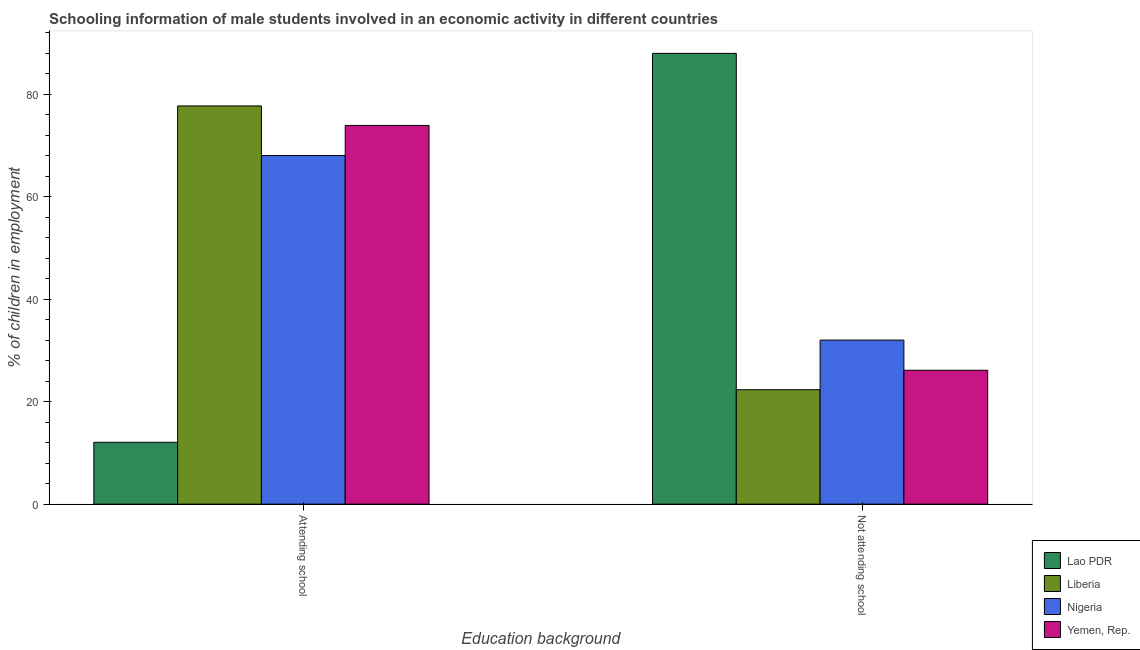How many different coloured bars are there?
Ensure brevity in your answer.  4. Are the number of bars per tick equal to the number of legend labels?
Your response must be concise. Yes. Are the number of bars on each tick of the X-axis equal?
Ensure brevity in your answer.  Yes. How many bars are there on the 2nd tick from the right?
Your response must be concise. 4. What is the label of the 1st group of bars from the left?
Give a very brief answer. Attending school. What is the percentage of employed males who are attending school in Liberia?
Your answer should be very brief. 77.68. Across all countries, what is the maximum percentage of employed males who are not attending school?
Provide a short and direct response. 87.93. Across all countries, what is the minimum percentage of employed males who are not attending school?
Make the answer very short. 22.32. In which country was the percentage of employed males who are not attending school maximum?
Give a very brief answer. Lao PDR. In which country was the percentage of employed males who are attending school minimum?
Offer a terse response. Lao PDR. What is the total percentage of employed males who are not attending school in the graph?
Offer a very short reply. 168.38. What is the difference between the percentage of employed males who are attending school in Liberia and that in Yemen, Rep.?
Give a very brief answer. 3.8. What is the difference between the percentage of employed males who are not attending school in Nigeria and the percentage of employed males who are attending school in Yemen, Rep.?
Offer a terse response. -41.88. What is the average percentage of employed males who are not attending school per country?
Ensure brevity in your answer.  42.09. What is the difference between the percentage of employed males who are not attending school and percentage of employed males who are attending school in Yemen, Rep.?
Ensure brevity in your answer.  -47.76. In how many countries, is the percentage of employed males who are not attending school greater than 16 %?
Keep it short and to the point. 4. What is the ratio of the percentage of employed males who are not attending school in Liberia to that in Lao PDR?
Provide a short and direct response. 0.25. Is the percentage of employed males who are not attending school in Liberia less than that in Yemen, Rep.?
Offer a very short reply. Yes. In how many countries, is the percentage of employed males who are attending school greater than the average percentage of employed males who are attending school taken over all countries?
Give a very brief answer. 3. What does the 3rd bar from the left in Not attending school represents?
Give a very brief answer. Nigeria. What does the 2nd bar from the right in Attending school represents?
Give a very brief answer. Nigeria. How many bars are there?
Keep it short and to the point. 8. Are all the bars in the graph horizontal?
Keep it short and to the point. No. Does the graph contain any zero values?
Your answer should be very brief. No. Does the graph contain grids?
Give a very brief answer. No. Where does the legend appear in the graph?
Offer a terse response. Bottom right. How many legend labels are there?
Keep it short and to the point. 4. How are the legend labels stacked?
Your response must be concise. Vertical. What is the title of the graph?
Provide a succinct answer. Schooling information of male students involved in an economic activity in different countries. What is the label or title of the X-axis?
Give a very brief answer. Education background. What is the label or title of the Y-axis?
Make the answer very short. % of children in employment. What is the % of children in employment in Lao PDR in Attending school?
Keep it short and to the point. 12.07. What is the % of children in employment in Liberia in Attending school?
Your response must be concise. 77.68. What is the % of children in employment of Nigeria in Attending school?
Provide a succinct answer. 68. What is the % of children in employment in Yemen, Rep. in Attending school?
Make the answer very short. 73.88. What is the % of children in employment in Lao PDR in Not attending school?
Provide a short and direct response. 87.93. What is the % of children in employment of Liberia in Not attending school?
Offer a terse response. 22.32. What is the % of children in employment of Yemen, Rep. in Not attending school?
Keep it short and to the point. 26.12. Across all Education background, what is the maximum % of children in employment of Lao PDR?
Provide a succinct answer. 87.93. Across all Education background, what is the maximum % of children in employment in Liberia?
Offer a terse response. 77.68. Across all Education background, what is the maximum % of children in employment in Nigeria?
Keep it short and to the point. 68. Across all Education background, what is the maximum % of children in employment in Yemen, Rep.?
Give a very brief answer. 73.88. Across all Education background, what is the minimum % of children in employment in Lao PDR?
Offer a terse response. 12.07. Across all Education background, what is the minimum % of children in employment of Liberia?
Your response must be concise. 22.32. Across all Education background, what is the minimum % of children in employment of Nigeria?
Your response must be concise. 32. Across all Education background, what is the minimum % of children in employment in Yemen, Rep.?
Give a very brief answer. 26.12. What is the total % of children in employment in Nigeria in the graph?
Make the answer very short. 100. What is the difference between the % of children in employment of Lao PDR in Attending school and that in Not attending school?
Offer a very short reply. -75.87. What is the difference between the % of children in employment in Liberia in Attending school and that in Not attending school?
Keep it short and to the point. 55.36. What is the difference between the % of children in employment of Yemen, Rep. in Attending school and that in Not attending school?
Ensure brevity in your answer.  47.76. What is the difference between the % of children in employment of Lao PDR in Attending school and the % of children in employment of Liberia in Not attending school?
Your answer should be very brief. -10.26. What is the difference between the % of children in employment in Lao PDR in Attending school and the % of children in employment in Nigeria in Not attending school?
Make the answer very short. -19.93. What is the difference between the % of children in employment in Lao PDR in Attending school and the % of children in employment in Yemen, Rep. in Not attending school?
Your answer should be compact. -14.06. What is the difference between the % of children in employment of Liberia in Attending school and the % of children in employment of Nigeria in Not attending school?
Your answer should be compact. 45.68. What is the difference between the % of children in employment of Liberia in Attending school and the % of children in employment of Yemen, Rep. in Not attending school?
Offer a very short reply. 51.56. What is the difference between the % of children in employment of Nigeria in Attending school and the % of children in employment of Yemen, Rep. in Not attending school?
Keep it short and to the point. 41.88. What is the difference between the % of children in employment of Lao PDR and % of children in employment of Liberia in Attending school?
Your response must be concise. -65.61. What is the difference between the % of children in employment of Lao PDR and % of children in employment of Nigeria in Attending school?
Make the answer very short. -55.93. What is the difference between the % of children in employment of Lao PDR and % of children in employment of Yemen, Rep. in Attending school?
Your response must be concise. -61.81. What is the difference between the % of children in employment in Liberia and % of children in employment in Nigeria in Attending school?
Give a very brief answer. 9.68. What is the difference between the % of children in employment in Liberia and % of children in employment in Yemen, Rep. in Attending school?
Offer a terse response. 3.8. What is the difference between the % of children in employment of Nigeria and % of children in employment of Yemen, Rep. in Attending school?
Make the answer very short. -5.88. What is the difference between the % of children in employment of Lao PDR and % of children in employment of Liberia in Not attending school?
Keep it short and to the point. 65.61. What is the difference between the % of children in employment of Lao PDR and % of children in employment of Nigeria in Not attending school?
Your response must be concise. 55.93. What is the difference between the % of children in employment of Lao PDR and % of children in employment of Yemen, Rep. in Not attending school?
Your response must be concise. 61.81. What is the difference between the % of children in employment in Liberia and % of children in employment in Nigeria in Not attending school?
Offer a very short reply. -9.68. What is the difference between the % of children in employment in Liberia and % of children in employment in Yemen, Rep. in Not attending school?
Keep it short and to the point. -3.8. What is the difference between the % of children in employment in Nigeria and % of children in employment in Yemen, Rep. in Not attending school?
Keep it short and to the point. 5.88. What is the ratio of the % of children in employment in Lao PDR in Attending school to that in Not attending school?
Make the answer very short. 0.14. What is the ratio of the % of children in employment in Liberia in Attending school to that in Not attending school?
Keep it short and to the point. 3.48. What is the ratio of the % of children in employment in Nigeria in Attending school to that in Not attending school?
Keep it short and to the point. 2.12. What is the ratio of the % of children in employment of Yemen, Rep. in Attending school to that in Not attending school?
Offer a very short reply. 2.83. What is the difference between the highest and the second highest % of children in employment of Lao PDR?
Your response must be concise. 75.87. What is the difference between the highest and the second highest % of children in employment of Liberia?
Your answer should be compact. 55.36. What is the difference between the highest and the second highest % of children in employment in Nigeria?
Your answer should be compact. 36. What is the difference between the highest and the second highest % of children in employment in Yemen, Rep.?
Your answer should be compact. 47.76. What is the difference between the highest and the lowest % of children in employment of Lao PDR?
Make the answer very short. 75.87. What is the difference between the highest and the lowest % of children in employment in Liberia?
Keep it short and to the point. 55.36. What is the difference between the highest and the lowest % of children in employment in Nigeria?
Provide a short and direct response. 36. What is the difference between the highest and the lowest % of children in employment of Yemen, Rep.?
Make the answer very short. 47.76. 